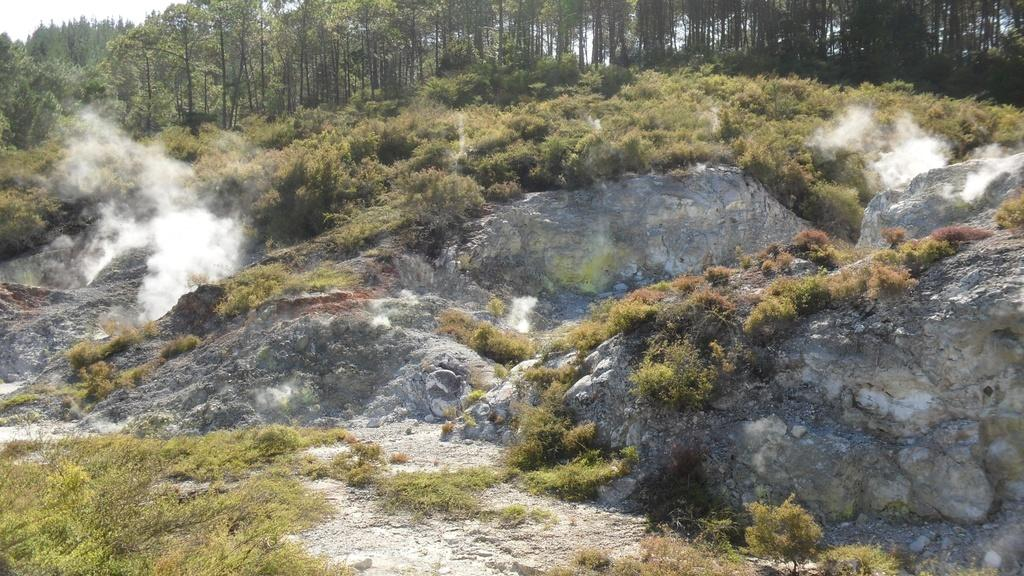What type of natural elements can be seen in the image? There are rocks in the image. Are there any living organisms growing on the rocks? Yes, there are plants on the rocks. What can be seen in the background of the image? There are trees in the background of the image. Can you see a tiger drinking from the lake in the image? There is no lake or tiger present in the image. What type of stem is supporting the plants on the rocks? The provided facts do not mention any stems; the plants are growing directly on the rocks. 